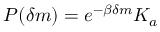Convert formula to latex. <formula><loc_0><loc_0><loc_500><loc_500>P ( \delta m ) = e ^ { - \beta \delta m } K _ { a }</formula> 